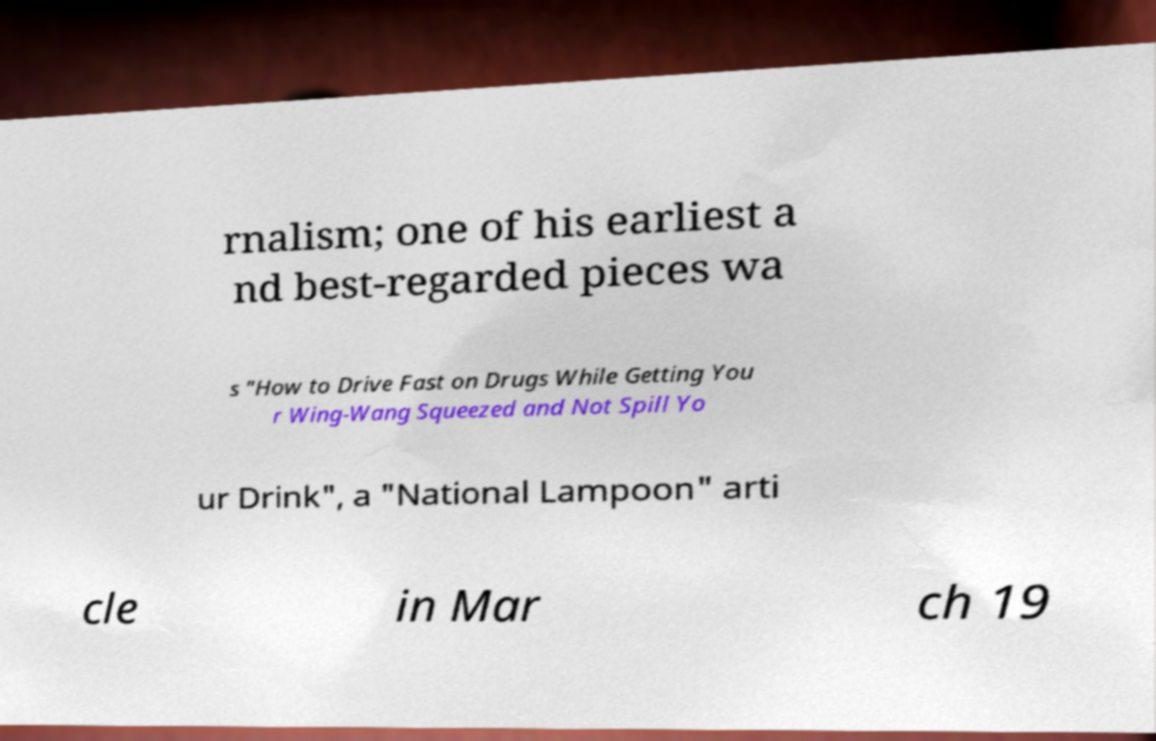There's text embedded in this image that I need extracted. Can you transcribe it verbatim? rnalism; one of his earliest a nd best-regarded pieces wa s "How to Drive Fast on Drugs While Getting You r Wing-Wang Squeezed and Not Spill Yo ur Drink", a "National Lampoon" arti cle in Mar ch 19 